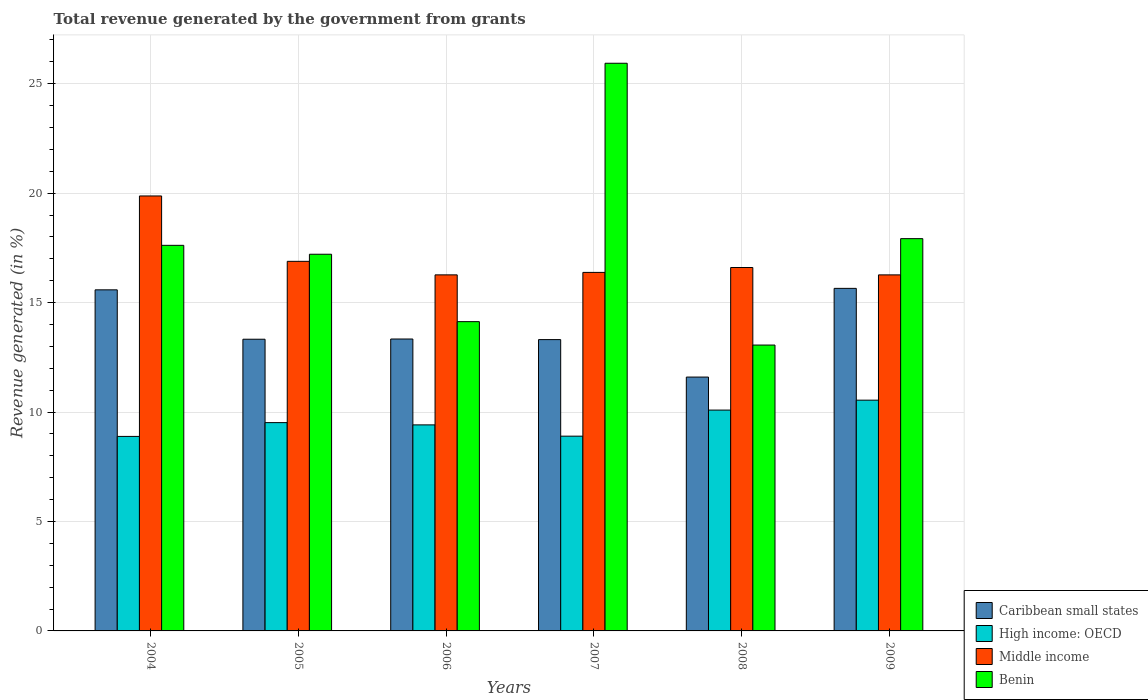Are the number of bars per tick equal to the number of legend labels?
Make the answer very short. Yes. Are the number of bars on each tick of the X-axis equal?
Offer a very short reply. Yes. How many bars are there on the 1st tick from the left?
Ensure brevity in your answer.  4. How many bars are there on the 5th tick from the right?
Give a very brief answer. 4. What is the label of the 2nd group of bars from the left?
Your response must be concise. 2005. What is the total revenue generated in Caribbean small states in 2008?
Provide a short and direct response. 11.6. Across all years, what is the maximum total revenue generated in High income: OECD?
Provide a succinct answer. 10.54. Across all years, what is the minimum total revenue generated in Benin?
Make the answer very short. 13.06. What is the total total revenue generated in Caribbean small states in the graph?
Your response must be concise. 82.81. What is the difference between the total revenue generated in Benin in 2004 and that in 2008?
Make the answer very short. 4.56. What is the difference between the total revenue generated in Middle income in 2009 and the total revenue generated in High income: OECD in 2004?
Keep it short and to the point. 7.38. What is the average total revenue generated in Middle income per year?
Provide a short and direct response. 17.05. In the year 2007, what is the difference between the total revenue generated in Caribbean small states and total revenue generated in High income: OECD?
Ensure brevity in your answer.  4.41. What is the ratio of the total revenue generated in Benin in 2006 to that in 2007?
Provide a succinct answer. 0.54. Is the difference between the total revenue generated in Caribbean small states in 2005 and 2008 greater than the difference between the total revenue generated in High income: OECD in 2005 and 2008?
Provide a succinct answer. Yes. What is the difference between the highest and the second highest total revenue generated in Benin?
Your response must be concise. 8.01. What is the difference between the highest and the lowest total revenue generated in Middle income?
Provide a short and direct response. 3.61. In how many years, is the total revenue generated in Middle income greater than the average total revenue generated in Middle income taken over all years?
Provide a succinct answer. 1. Is the sum of the total revenue generated in Middle income in 2006 and 2009 greater than the maximum total revenue generated in Caribbean small states across all years?
Provide a short and direct response. Yes. Is it the case that in every year, the sum of the total revenue generated in High income: OECD and total revenue generated in Benin is greater than the sum of total revenue generated in Caribbean small states and total revenue generated in Middle income?
Your answer should be very brief. Yes. What does the 1st bar from the left in 2008 represents?
Give a very brief answer. Caribbean small states. What does the 4th bar from the right in 2006 represents?
Provide a short and direct response. Caribbean small states. Is it the case that in every year, the sum of the total revenue generated in Caribbean small states and total revenue generated in Middle income is greater than the total revenue generated in High income: OECD?
Your answer should be compact. Yes. How many bars are there?
Make the answer very short. 24. How many years are there in the graph?
Your response must be concise. 6. Are the values on the major ticks of Y-axis written in scientific E-notation?
Your answer should be very brief. No. Does the graph contain grids?
Offer a terse response. Yes. Where does the legend appear in the graph?
Ensure brevity in your answer.  Bottom right. How many legend labels are there?
Your answer should be compact. 4. What is the title of the graph?
Give a very brief answer. Total revenue generated by the government from grants. Does "Turkey" appear as one of the legend labels in the graph?
Give a very brief answer. No. What is the label or title of the X-axis?
Make the answer very short. Years. What is the label or title of the Y-axis?
Offer a very short reply. Revenue generated (in %). What is the Revenue generated (in %) in Caribbean small states in 2004?
Provide a succinct answer. 15.58. What is the Revenue generated (in %) of High income: OECD in 2004?
Provide a succinct answer. 8.89. What is the Revenue generated (in %) of Middle income in 2004?
Your answer should be compact. 19.87. What is the Revenue generated (in %) of Benin in 2004?
Give a very brief answer. 17.62. What is the Revenue generated (in %) in Caribbean small states in 2005?
Offer a very short reply. 13.33. What is the Revenue generated (in %) in High income: OECD in 2005?
Give a very brief answer. 9.52. What is the Revenue generated (in %) of Middle income in 2005?
Ensure brevity in your answer.  16.89. What is the Revenue generated (in %) in Benin in 2005?
Your response must be concise. 17.21. What is the Revenue generated (in %) in Caribbean small states in 2006?
Ensure brevity in your answer.  13.34. What is the Revenue generated (in %) in High income: OECD in 2006?
Provide a succinct answer. 9.41. What is the Revenue generated (in %) of Middle income in 2006?
Your answer should be compact. 16.27. What is the Revenue generated (in %) in Benin in 2006?
Ensure brevity in your answer.  14.13. What is the Revenue generated (in %) of Caribbean small states in 2007?
Give a very brief answer. 13.31. What is the Revenue generated (in %) of High income: OECD in 2007?
Provide a succinct answer. 8.9. What is the Revenue generated (in %) of Middle income in 2007?
Offer a terse response. 16.38. What is the Revenue generated (in %) in Benin in 2007?
Give a very brief answer. 25.94. What is the Revenue generated (in %) in Caribbean small states in 2008?
Your response must be concise. 11.6. What is the Revenue generated (in %) of High income: OECD in 2008?
Provide a short and direct response. 10.09. What is the Revenue generated (in %) of Middle income in 2008?
Make the answer very short. 16.6. What is the Revenue generated (in %) in Benin in 2008?
Give a very brief answer. 13.06. What is the Revenue generated (in %) of Caribbean small states in 2009?
Provide a short and direct response. 15.65. What is the Revenue generated (in %) of High income: OECD in 2009?
Your response must be concise. 10.54. What is the Revenue generated (in %) in Middle income in 2009?
Offer a terse response. 16.27. What is the Revenue generated (in %) of Benin in 2009?
Give a very brief answer. 17.92. Across all years, what is the maximum Revenue generated (in %) in Caribbean small states?
Your answer should be very brief. 15.65. Across all years, what is the maximum Revenue generated (in %) in High income: OECD?
Keep it short and to the point. 10.54. Across all years, what is the maximum Revenue generated (in %) of Middle income?
Give a very brief answer. 19.87. Across all years, what is the maximum Revenue generated (in %) in Benin?
Provide a short and direct response. 25.94. Across all years, what is the minimum Revenue generated (in %) in Caribbean small states?
Provide a short and direct response. 11.6. Across all years, what is the minimum Revenue generated (in %) of High income: OECD?
Give a very brief answer. 8.89. Across all years, what is the minimum Revenue generated (in %) in Middle income?
Keep it short and to the point. 16.27. Across all years, what is the minimum Revenue generated (in %) in Benin?
Offer a very short reply. 13.06. What is the total Revenue generated (in %) of Caribbean small states in the graph?
Offer a very short reply. 82.81. What is the total Revenue generated (in %) in High income: OECD in the graph?
Keep it short and to the point. 57.35. What is the total Revenue generated (in %) in Middle income in the graph?
Your answer should be compact. 102.28. What is the total Revenue generated (in %) of Benin in the graph?
Your answer should be very brief. 105.88. What is the difference between the Revenue generated (in %) of Caribbean small states in 2004 and that in 2005?
Give a very brief answer. 2.26. What is the difference between the Revenue generated (in %) of High income: OECD in 2004 and that in 2005?
Offer a very short reply. -0.63. What is the difference between the Revenue generated (in %) in Middle income in 2004 and that in 2005?
Provide a succinct answer. 2.99. What is the difference between the Revenue generated (in %) of Benin in 2004 and that in 2005?
Your answer should be very brief. 0.41. What is the difference between the Revenue generated (in %) of Caribbean small states in 2004 and that in 2006?
Give a very brief answer. 2.25. What is the difference between the Revenue generated (in %) of High income: OECD in 2004 and that in 2006?
Your answer should be compact. -0.53. What is the difference between the Revenue generated (in %) in Middle income in 2004 and that in 2006?
Your answer should be compact. 3.61. What is the difference between the Revenue generated (in %) in Benin in 2004 and that in 2006?
Make the answer very short. 3.49. What is the difference between the Revenue generated (in %) of Caribbean small states in 2004 and that in 2007?
Ensure brevity in your answer.  2.27. What is the difference between the Revenue generated (in %) in High income: OECD in 2004 and that in 2007?
Give a very brief answer. -0.01. What is the difference between the Revenue generated (in %) of Middle income in 2004 and that in 2007?
Your answer should be very brief. 3.49. What is the difference between the Revenue generated (in %) in Benin in 2004 and that in 2007?
Your answer should be very brief. -8.32. What is the difference between the Revenue generated (in %) of Caribbean small states in 2004 and that in 2008?
Provide a short and direct response. 3.99. What is the difference between the Revenue generated (in %) of High income: OECD in 2004 and that in 2008?
Ensure brevity in your answer.  -1.2. What is the difference between the Revenue generated (in %) of Middle income in 2004 and that in 2008?
Your answer should be very brief. 3.27. What is the difference between the Revenue generated (in %) in Benin in 2004 and that in 2008?
Keep it short and to the point. 4.56. What is the difference between the Revenue generated (in %) in Caribbean small states in 2004 and that in 2009?
Provide a short and direct response. -0.07. What is the difference between the Revenue generated (in %) of High income: OECD in 2004 and that in 2009?
Your response must be concise. -1.66. What is the difference between the Revenue generated (in %) in Middle income in 2004 and that in 2009?
Offer a terse response. 3.61. What is the difference between the Revenue generated (in %) of Benin in 2004 and that in 2009?
Keep it short and to the point. -0.31. What is the difference between the Revenue generated (in %) of Caribbean small states in 2005 and that in 2006?
Offer a very short reply. -0.01. What is the difference between the Revenue generated (in %) in High income: OECD in 2005 and that in 2006?
Make the answer very short. 0.1. What is the difference between the Revenue generated (in %) of Middle income in 2005 and that in 2006?
Ensure brevity in your answer.  0.62. What is the difference between the Revenue generated (in %) of Benin in 2005 and that in 2006?
Your response must be concise. 3.08. What is the difference between the Revenue generated (in %) of Caribbean small states in 2005 and that in 2007?
Offer a very short reply. 0.02. What is the difference between the Revenue generated (in %) in High income: OECD in 2005 and that in 2007?
Your answer should be very brief. 0.62. What is the difference between the Revenue generated (in %) in Middle income in 2005 and that in 2007?
Keep it short and to the point. 0.51. What is the difference between the Revenue generated (in %) of Benin in 2005 and that in 2007?
Offer a terse response. -8.73. What is the difference between the Revenue generated (in %) in Caribbean small states in 2005 and that in 2008?
Make the answer very short. 1.73. What is the difference between the Revenue generated (in %) in High income: OECD in 2005 and that in 2008?
Provide a short and direct response. -0.57. What is the difference between the Revenue generated (in %) in Middle income in 2005 and that in 2008?
Keep it short and to the point. 0.28. What is the difference between the Revenue generated (in %) in Benin in 2005 and that in 2008?
Give a very brief answer. 4.15. What is the difference between the Revenue generated (in %) of Caribbean small states in 2005 and that in 2009?
Provide a short and direct response. -2.32. What is the difference between the Revenue generated (in %) in High income: OECD in 2005 and that in 2009?
Your answer should be compact. -1.03. What is the difference between the Revenue generated (in %) in Middle income in 2005 and that in 2009?
Provide a short and direct response. 0.62. What is the difference between the Revenue generated (in %) in Benin in 2005 and that in 2009?
Ensure brevity in your answer.  -0.71. What is the difference between the Revenue generated (in %) of Caribbean small states in 2006 and that in 2007?
Keep it short and to the point. 0.03. What is the difference between the Revenue generated (in %) of High income: OECD in 2006 and that in 2007?
Offer a terse response. 0.51. What is the difference between the Revenue generated (in %) in Middle income in 2006 and that in 2007?
Your answer should be very brief. -0.11. What is the difference between the Revenue generated (in %) of Benin in 2006 and that in 2007?
Offer a very short reply. -11.81. What is the difference between the Revenue generated (in %) in Caribbean small states in 2006 and that in 2008?
Make the answer very short. 1.74. What is the difference between the Revenue generated (in %) in High income: OECD in 2006 and that in 2008?
Offer a terse response. -0.68. What is the difference between the Revenue generated (in %) in Middle income in 2006 and that in 2008?
Your response must be concise. -0.34. What is the difference between the Revenue generated (in %) in Benin in 2006 and that in 2008?
Give a very brief answer. 1.07. What is the difference between the Revenue generated (in %) of Caribbean small states in 2006 and that in 2009?
Offer a very short reply. -2.31. What is the difference between the Revenue generated (in %) of High income: OECD in 2006 and that in 2009?
Keep it short and to the point. -1.13. What is the difference between the Revenue generated (in %) of Middle income in 2006 and that in 2009?
Offer a very short reply. 0. What is the difference between the Revenue generated (in %) of Benin in 2006 and that in 2009?
Provide a short and direct response. -3.79. What is the difference between the Revenue generated (in %) of Caribbean small states in 2007 and that in 2008?
Give a very brief answer. 1.71. What is the difference between the Revenue generated (in %) of High income: OECD in 2007 and that in 2008?
Your answer should be very brief. -1.19. What is the difference between the Revenue generated (in %) in Middle income in 2007 and that in 2008?
Your answer should be compact. -0.22. What is the difference between the Revenue generated (in %) in Benin in 2007 and that in 2008?
Provide a succinct answer. 12.87. What is the difference between the Revenue generated (in %) in Caribbean small states in 2007 and that in 2009?
Your answer should be compact. -2.34. What is the difference between the Revenue generated (in %) in High income: OECD in 2007 and that in 2009?
Offer a terse response. -1.64. What is the difference between the Revenue generated (in %) of Middle income in 2007 and that in 2009?
Your answer should be very brief. 0.11. What is the difference between the Revenue generated (in %) of Benin in 2007 and that in 2009?
Ensure brevity in your answer.  8.01. What is the difference between the Revenue generated (in %) of Caribbean small states in 2008 and that in 2009?
Offer a very short reply. -4.05. What is the difference between the Revenue generated (in %) in High income: OECD in 2008 and that in 2009?
Provide a succinct answer. -0.45. What is the difference between the Revenue generated (in %) in Middle income in 2008 and that in 2009?
Keep it short and to the point. 0.34. What is the difference between the Revenue generated (in %) of Benin in 2008 and that in 2009?
Make the answer very short. -4.86. What is the difference between the Revenue generated (in %) of Caribbean small states in 2004 and the Revenue generated (in %) of High income: OECD in 2005?
Your answer should be very brief. 6.07. What is the difference between the Revenue generated (in %) of Caribbean small states in 2004 and the Revenue generated (in %) of Middle income in 2005?
Your answer should be very brief. -1.3. What is the difference between the Revenue generated (in %) in Caribbean small states in 2004 and the Revenue generated (in %) in Benin in 2005?
Make the answer very short. -1.63. What is the difference between the Revenue generated (in %) in High income: OECD in 2004 and the Revenue generated (in %) in Middle income in 2005?
Your response must be concise. -8. What is the difference between the Revenue generated (in %) of High income: OECD in 2004 and the Revenue generated (in %) of Benin in 2005?
Your answer should be compact. -8.32. What is the difference between the Revenue generated (in %) in Middle income in 2004 and the Revenue generated (in %) in Benin in 2005?
Ensure brevity in your answer.  2.66. What is the difference between the Revenue generated (in %) of Caribbean small states in 2004 and the Revenue generated (in %) of High income: OECD in 2006?
Make the answer very short. 6.17. What is the difference between the Revenue generated (in %) in Caribbean small states in 2004 and the Revenue generated (in %) in Middle income in 2006?
Your response must be concise. -0.68. What is the difference between the Revenue generated (in %) of Caribbean small states in 2004 and the Revenue generated (in %) of Benin in 2006?
Your response must be concise. 1.45. What is the difference between the Revenue generated (in %) in High income: OECD in 2004 and the Revenue generated (in %) in Middle income in 2006?
Your response must be concise. -7.38. What is the difference between the Revenue generated (in %) of High income: OECD in 2004 and the Revenue generated (in %) of Benin in 2006?
Your answer should be compact. -5.24. What is the difference between the Revenue generated (in %) of Middle income in 2004 and the Revenue generated (in %) of Benin in 2006?
Give a very brief answer. 5.74. What is the difference between the Revenue generated (in %) in Caribbean small states in 2004 and the Revenue generated (in %) in High income: OECD in 2007?
Offer a terse response. 6.69. What is the difference between the Revenue generated (in %) in Caribbean small states in 2004 and the Revenue generated (in %) in Middle income in 2007?
Give a very brief answer. -0.8. What is the difference between the Revenue generated (in %) in Caribbean small states in 2004 and the Revenue generated (in %) in Benin in 2007?
Provide a short and direct response. -10.35. What is the difference between the Revenue generated (in %) of High income: OECD in 2004 and the Revenue generated (in %) of Middle income in 2007?
Offer a very short reply. -7.49. What is the difference between the Revenue generated (in %) of High income: OECD in 2004 and the Revenue generated (in %) of Benin in 2007?
Provide a short and direct response. -17.05. What is the difference between the Revenue generated (in %) in Middle income in 2004 and the Revenue generated (in %) in Benin in 2007?
Offer a terse response. -6.06. What is the difference between the Revenue generated (in %) of Caribbean small states in 2004 and the Revenue generated (in %) of High income: OECD in 2008?
Offer a very short reply. 5.49. What is the difference between the Revenue generated (in %) in Caribbean small states in 2004 and the Revenue generated (in %) in Middle income in 2008?
Offer a terse response. -1.02. What is the difference between the Revenue generated (in %) in Caribbean small states in 2004 and the Revenue generated (in %) in Benin in 2008?
Make the answer very short. 2.52. What is the difference between the Revenue generated (in %) of High income: OECD in 2004 and the Revenue generated (in %) of Middle income in 2008?
Your answer should be very brief. -7.72. What is the difference between the Revenue generated (in %) in High income: OECD in 2004 and the Revenue generated (in %) in Benin in 2008?
Keep it short and to the point. -4.17. What is the difference between the Revenue generated (in %) in Middle income in 2004 and the Revenue generated (in %) in Benin in 2008?
Offer a terse response. 6.81. What is the difference between the Revenue generated (in %) in Caribbean small states in 2004 and the Revenue generated (in %) in High income: OECD in 2009?
Make the answer very short. 5.04. What is the difference between the Revenue generated (in %) of Caribbean small states in 2004 and the Revenue generated (in %) of Middle income in 2009?
Provide a short and direct response. -0.68. What is the difference between the Revenue generated (in %) in Caribbean small states in 2004 and the Revenue generated (in %) in Benin in 2009?
Your answer should be very brief. -2.34. What is the difference between the Revenue generated (in %) of High income: OECD in 2004 and the Revenue generated (in %) of Middle income in 2009?
Give a very brief answer. -7.38. What is the difference between the Revenue generated (in %) of High income: OECD in 2004 and the Revenue generated (in %) of Benin in 2009?
Your answer should be compact. -9.04. What is the difference between the Revenue generated (in %) in Middle income in 2004 and the Revenue generated (in %) in Benin in 2009?
Offer a terse response. 1.95. What is the difference between the Revenue generated (in %) of Caribbean small states in 2005 and the Revenue generated (in %) of High income: OECD in 2006?
Your answer should be compact. 3.91. What is the difference between the Revenue generated (in %) in Caribbean small states in 2005 and the Revenue generated (in %) in Middle income in 2006?
Your answer should be compact. -2.94. What is the difference between the Revenue generated (in %) in Caribbean small states in 2005 and the Revenue generated (in %) in Benin in 2006?
Your answer should be compact. -0.8. What is the difference between the Revenue generated (in %) of High income: OECD in 2005 and the Revenue generated (in %) of Middle income in 2006?
Your response must be concise. -6.75. What is the difference between the Revenue generated (in %) in High income: OECD in 2005 and the Revenue generated (in %) in Benin in 2006?
Offer a terse response. -4.61. What is the difference between the Revenue generated (in %) of Middle income in 2005 and the Revenue generated (in %) of Benin in 2006?
Offer a terse response. 2.76. What is the difference between the Revenue generated (in %) of Caribbean small states in 2005 and the Revenue generated (in %) of High income: OECD in 2007?
Your response must be concise. 4.43. What is the difference between the Revenue generated (in %) in Caribbean small states in 2005 and the Revenue generated (in %) in Middle income in 2007?
Your answer should be very brief. -3.05. What is the difference between the Revenue generated (in %) of Caribbean small states in 2005 and the Revenue generated (in %) of Benin in 2007?
Make the answer very short. -12.61. What is the difference between the Revenue generated (in %) in High income: OECD in 2005 and the Revenue generated (in %) in Middle income in 2007?
Offer a terse response. -6.86. What is the difference between the Revenue generated (in %) in High income: OECD in 2005 and the Revenue generated (in %) in Benin in 2007?
Offer a terse response. -16.42. What is the difference between the Revenue generated (in %) of Middle income in 2005 and the Revenue generated (in %) of Benin in 2007?
Keep it short and to the point. -9.05. What is the difference between the Revenue generated (in %) in Caribbean small states in 2005 and the Revenue generated (in %) in High income: OECD in 2008?
Ensure brevity in your answer.  3.24. What is the difference between the Revenue generated (in %) of Caribbean small states in 2005 and the Revenue generated (in %) of Middle income in 2008?
Offer a very short reply. -3.28. What is the difference between the Revenue generated (in %) of Caribbean small states in 2005 and the Revenue generated (in %) of Benin in 2008?
Provide a succinct answer. 0.27. What is the difference between the Revenue generated (in %) in High income: OECD in 2005 and the Revenue generated (in %) in Middle income in 2008?
Ensure brevity in your answer.  -7.09. What is the difference between the Revenue generated (in %) of High income: OECD in 2005 and the Revenue generated (in %) of Benin in 2008?
Your answer should be compact. -3.54. What is the difference between the Revenue generated (in %) in Middle income in 2005 and the Revenue generated (in %) in Benin in 2008?
Provide a succinct answer. 3.82. What is the difference between the Revenue generated (in %) in Caribbean small states in 2005 and the Revenue generated (in %) in High income: OECD in 2009?
Keep it short and to the point. 2.78. What is the difference between the Revenue generated (in %) in Caribbean small states in 2005 and the Revenue generated (in %) in Middle income in 2009?
Your answer should be very brief. -2.94. What is the difference between the Revenue generated (in %) of Caribbean small states in 2005 and the Revenue generated (in %) of Benin in 2009?
Your answer should be compact. -4.6. What is the difference between the Revenue generated (in %) in High income: OECD in 2005 and the Revenue generated (in %) in Middle income in 2009?
Provide a succinct answer. -6.75. What is the difference between the Revenue generated (in %) of High income: OECD in 2005 and the Revenue generated (in %) of Benin in 2009?
Your response must be concise. -8.4. What is the difference between the Revenue generated (in %) of Middle income in 2005 and the Revenue generated (in %) of Benin in 2009?
Your answer should be very brief. -1.04. What is the difference between the Revenue generated (in %) in Caribbean small states in 2006 and the Revenue generated (in %) in High income: OECD in 2007?
Your answer should be very brief. 4.44. What is the difference between the Revenue generated (in %) in Caribbean small states in 2006 and the Revenue generated (in %) in Middle income in 2007?
Offer a terse response. -3.04. What is the difference between the Revenue generated (in %) in Caribbean small states in 2006 and the Revenue generated (in %) in Benin in 2007?
Provide a short and direct response. -12.6. What is the difference between the Revenue generated (in %) in High income: OECD in 2006 and the Revenue generated (in %) in Middle income in 2007?
Your answer should be compact. -6.97. What is the difference between the Revenue generated (in %) of High income: OECD in 2006 and the Revenue generated (in %) of Benin in 2007?
Offer a very short reply. -16.52. What is the difference between the Revenue generated (in %) in Middle income in 2006 and the Revenue generated (in %) in Benin in 2007?
Make the answer very short. -9.67. What is the difference between the Revenue generated (in %) of Caribbean small states in 2006 and the Revenue generated (in %) of High income: OECD in 2008?
Make the answer very short. 3.25. What is the difference between the Revenue generated (in %) in Caribbean small states in 2006 and the Revenue generated (in %) in Middle income in 2008?
Provide a succinct answer. -3.27. What is the difference between the Revenue generated (in %) in Caribbean small states in 2006 and the Revenue generated (in %) in Benin in 2008?
Ensure brevity in your answer.  0.28. What is the difference between the Revenue generated (in %) in High income: OECD in 2006 and the Revenue generated (in %) in Middle income in 2008?
Your answer should be compact. -7.19. What is the difference between the Revenue generated (in %) of High income: OECD in 2006 and the Revenue generated (in %) of Benin in 2008?
Offer a terse response. -3.65. What is the difference between the Revenue generated (in %) in Middle income in 2006 and the Revenue generated (in %) in Benin in 2008?
Provide a succinct answer. 3.21. What is the difference between the Revenue generated (in %) of Caribbean small states in 2006 and the Revenue generated (in %) of High income: OECD in 2009?
Make the answer very short. 2.79. What is the difference between the Revenue generated (in %) of Caribbean small states in 2006 and the Revenue generated (in %) of Middle income in 2009?
Provide a short and direct response. -2.93. What is the difference between the Revenue generated (in %) in Caribbean small states in 2006 and the Revenue generated (in %) in Benin in 2009?
Keep it short and to the point. -4.59. What is the difference between the Revenue generated (in %) of High income: OECD in 2006 and the Revenue generated (in %) of Middle income in 2009?
Make the answer very short. -6.85. What is the difference between the Revenue generated (in %) in High income: OECD in 2006 and the Revenue generated (in %) in Benin in 2009?
Your answer should be compact. -8.51. What is the difference between the Revenue generated (in %) in Middle income in 2006 and the Revenue generated (in %) in Benin in 2009?
Your response must be concise. -1.65. What is the difference between the Revenue generated (in %) in Caribbean small states in 2007 and the Revenue generated (in %) in High income: OECD in 2008?
Make the answer very short. 3.22. What is the difference between the Revenue generated (in %) in Caribbean small states in 2007 and the Revenue generated (in %) in Middle income in 2008?
Your answer should be very brief. -3.29. What is the difference between the Revenue generated (in %) in Caribbean small states in 2007 and the Revenue generated (in %) in Benin in 2008?
Offer a very short reply. 0.25. What is the difference between the Revenue generated (in %) in High income: OECD in 2007 and the Revenue generated (in %) in Middle income in 2008?
Give a very brief answer. -7.71. What is the difference between the Revenue generated (in %) of High income: OECD in 2007 and the Revenue generated (in %) of Benin in 2008?
Your answer should be very brief. -4.16. What is the difference between the Revenue generated (in %) in Middle income in 2007 and the Revenue generated (in %) in Benin in 2008?
Your answer should be compact. 3.32. What is the difference between the Revenue generated (in %) of Caribbean small states in 2007 and the Revenue generated (in %) of High income: OECD in 2009?
Keep it short and to the point. 2.77. What is the difference between the Revenue generated (in %) in Caribbean small states in 2007 and the Revenue generated (in %) in Middle income in 2009?
Your response must be concise. -2.96. What is the difference between the Revenue generated (in %) in Caribbean small states in 2007 and the Revenue generated (in %) in Benin in 2009?
Make the answer very short. -4.61. What is the difference between the Revenue generated (in %) in High income: OECD in 2007 and the Revenue generated (in %) in Middle income in 2009?
Your answer should be very brief. -7.37. What is the difference between the Revenue generated (in %) of High income: OECD in 2007 and the Revenue generated (in %) of Benin in 2009?
Make the answer very short. -9.02. What is the difference between the Revenue generated (in %) in Middle income in 2007 and the Revenue generated (in %) in Benin in 2009?
Your answer should be very brief. -1.54. What is the difference between the Revenue generated (in %) in Caribbean small states in 2008 and the Revenue generated (in %) in High income: OECD in 2009?
Keep it short and to the point. 1.06. What is the difference between the Revenue generated (in %) in Caribbean small states in 2008 and the Revenue generated (in %) in Middle income in 2009?
Ensure brevity in your answer.  -4.67. What is the difference between the Revenue generated (in %) of Caribbean small states in 2008 and the Revenue generated (in %) of Benin in 2009?
Provide a succinct answer. -6.32. What is the difference between the Revenue generated (in %) of High income: OECD in 2008 and the Revenue generated (in %) of Middle income in 2009?
Keep it short and to the point. -6.18. What is the difference between the Revenue generated (in %) in High income: OECD in 2008 and the Revenue generated (in %) in Benin in 2009?
Make the answer very short. -7.83. What is the difference between the Revenue generated (in %) of Middle income in 2008 and the Revenue generated (in %) of Benin in 2009?
Provide a succinct answer. -1.32. What is the average Revenue generated (in %) of Caribbean small states per year?
Offer a terse response. 13.8. What is the average Revenue generated (in %) of High income: OECD per year?
Provide a succinct answer. 9.56. What is the average Revenue generated (in %) of Middle income per year?
Give a very brief answer. 17.05. What is the average Revenue generated (in %) of Benin per year?
Your answer should be compact. 17.65. In the year 2004, what is the difference between the Revenue generated (in %) of Caribbean small states and Revenue generated (in %) of High income: OECD?
Provide a short and direct response. 6.7. In the year 2004, what is the difference between the Revenue generated (in %) in Caribbean small states and Revenue generated (in %) in Middle income?
Provide a short and direct response. -4.29. In the year 2004, what is the difference between the Revenue generated (in %) of Caribbean small states and Revenue generated (in %) of Benin?
Your response must be concise. -2.03. In the year 2004, what is the difference between the Revenue generated (in %) of High income: OECD and Revenue generated (in %) of Middle income?
Provide a short and direct response. -10.99. In the year 2004, what is the difference between the Revenue generated (in %) in High income: OECD and Revenue generated (in %) in Benin?
Offer a terse response. -8.73. In the year 2004, what is the difference between the Revenue generated (in %) in Middle income and Revenue generated (in %) in Benin?
Give a very brief answer. 2.26. In the year 2005, what is the difference between the Revenue generated (in %) of Caribbean small states and Revenue generated (in %) of High income: OECD?
Your answer should be very brief. 3.81. In the year 2005, what is the difference between the Revenue generated (in %) of Caribbean small states and Revenue generated (in %) of Middle income?
Ensure brevity in your answer.  -3.56. In the year 2005, what is the difference between the Revenue generated (in %) in Caribbean small states and Revenue generated (in %) in Benin?
Your response must be concise. -3.88. In the year 2005, what is the difference between the Revenue generated (in %) in High income: OECD and Revenue generated (in %) in Middle income?
Ensure brevity in your answer.  -7.37. In the year 2005, what is the difference between the Revenue generated (in %) of High income: OECD and Revenue generated (in %) of Benin?
Provide a succinct answer. -7.69. In the year 2005, what is the difference between the Revenue generated (in %) of Middle income and Revenue generated (in %) of Benin?
Make the answer very short. -0.32. In the year 2006, what is the difference between the Revenue generated (in %) of Caribbean small states and Revenue generated (in %) of High income: OECD?
Give a very brief answer. 3.92. In the year 2006, what is the difference between the Revenue generated (in %) of Caribbean small states and Revenue generated (in %) of Middle income?
Keep it short and to the point. -2.93. In the year 2006, what is the difference between the Revenue generated (in %) of Caribbean small states and Revenue generated (in %) of Benin?
Make the answer very short. -0.79. In the year 2006, what is the difference between the Revenue generated (in %) in High income: OECD and Revenue generated (in %) in Middle income?
Your response must be concise. -6.85. In the year 2006, what is the difference between the Revenue generated (in %) in High income: OECD and Revenue generated (in %) in Benin?
Provide a short and direct response. -4.72. In the year 2006, what is the difference between the Revenue generated (in %) of Middle income and Revenue generated (in %) of Benin?
Keep it short and to the point. 2.14. In the year 2007, what is the difference between the Revenue generated (in %) of Caribbean small states and Revenue generated (in %) of High income: OECD?
Your answer should be very brief. 4.41. In the year 2007, what is the difference between the Revenue generated (in %) in Caribbean small states and Revenue generated (in %) in Middle income?
Offer a very short reply. -3.07. In the year 2007, what is the difference between the Revenue generated (in %) of Caribbean small states and Revenue generated (in %) of Benin?
Your response must be concise. -12.63. In the year 2007, what is the difference between the Revenue generated (in %) of High income: OECD and Revenue generated (in %) of Middle income?
Give a very brief answer. -7.48. In the year 2007, what is the difference between the Revenue generated (in %) in High income: OECD and Revenue generated (in %) in Benin?
Ensure brevity in your answer.  -17.04. In the year 2007, what is the difference between the Revenue generated (in %) in Middle income and Revenue generated (in %) in Benin?
Provide a short and direct response. -9.55. In the year 2008, what is the difference between the Revenue generated (in %) of Caribbean small states and Revenue generated (in %) of High income: OECD?
Provide a short and direct response. 1.51. In the year 2008, what is the difference between the Revenue generated (in %) of Caribbean small states and Revenue generated (in %) of Middle income?
Give a very brief answer. -5.01. In the year 2008, what is the difference between the Revenue generated (in %) in Caribbean small states and Revenue generated (in %) in Benin?
Your answer should be compact. -1.46. In the year 2008, what is the difference between the Revenue generated (in %) in High income: OECD and Revenue generated (in %) in Middle income?
Provide a succinct answer. -6.51. In the year 2008, what is the difference between the Revenue generated (in %) in High income: OECD and Revenue generated (in %) in Benin?
Ensure brevity in your answer.  -2.97. In the year 2008, what is the difference between the Revenue generated (in %) in Middle income and Revenue generated (in %) in Benin?
Keep it short and to the point. 3.54. In the year 2009, what is the difference between the Revenue generated (in %) in Caribbean small states and Revenue generated (in %) in High income: OECD?
Provide a short and direct response. 5.11. In the year 2009, what is the difference between the Revenue generated (in %) of Caribbean small states and Revenue generated (in %) of Middle income?
Ensure brevity in your answer.  -0.62. In the year 2009, what is the difference between the Revenue generated (in %) of Caribbean small states and Revenue generated (in %) of Benin?
Keep it short and to the point. -2.27. In the year 2009, what is the difference between the Revenue generated (in %) in High income: OECD and Revenue generated (in %) in Middle income?
Your response must be concise. -5.72. In the year 2009, what is the difference between the Revenue generated (in %) in High income: OECD and Revenue generated (in %) in Benin?
Give a very brief answer. -7.38. In the year 2009, what is the difference between the Revenue generated (in %) in Middle income and Revenue generated (in %) in Benin?
Your answer should be very brief. -1.66. What is the ratio of the Revenue generated (in %) of Caribbean small states in 2004 to that in 2005?
Offer a terse response. 1.17. What is the ratio of the Revenue generated (in %) of High income: OECD in 2004 to that in 2005?
Keep it short and to the point. 0.93. What is the ratio of the Revenue generated (in %) of Middle income in 2004 to that in 2005?
Give a very brief answer. 1.18. What is the ratio of the Revenue generated (in %) of Benin in 2004 to that in 2005?
Your response must be concise. 1.02. What is the ratio of the Revenue generated (in %) of Caribbean small states in 2004 to that in 2006?
Give a very brief answer. 1.17. What is the ratio of the Revenue generated (in %) of High income: OECD in 2004 to that in 2006?
Offer a terse response. 0.94. What is the ratio of the Revenue generated (in %) of Middle income in 2004 to that in 2006?
Your answer should be compact. 1.22. What is the ratio of the Revenue generated (in %) in Benin in 2004 to that in 2006?
Ensure brevity in your answer.  1.25. What is the ratio of the Revenue generated (in %) in Caribbean small states in 2004 to that in 2007?
Give a very brief answer. 1.17. What is the ratio of the Revenue generated (in %) in Middle income in 2004 to that in 2007?
Your answer should be compact. 1.21. What is the ratio of the Revenue generated (in %) of Benin in 2004 to that in 2007?
Your response must be concise. 0.68. What is the ratio of the Revenue generated (in %) in Caribbean small states in 2004 to that in 2008?
Provide a short and direct response. 1.34. What is the ratio of the Revenue generated (in %) of High income: OECD in 2004 to that in 2008?
Make the answer very short. 0.88. What is the ratio of the Revenue generated (in %) of Middle income in 2004 to that in 2008?
Keep it short and to the point. 1.2. What is the ratio of the Revenue generated (in %) of Benin in 2004 to that in 2008?
Ensure brevity in your answer.  1.35. What is the ratio of the Revenue generated (in %) in Caribbean small states in 2004 to that in 2009?
Provide a succinct answer. 1. What is the ratio of the Revenue generated (in %) of High income: OECD in 2004 to that in 2009?
Your answer should be compact. 0.84. What is the ratio of the Revenue generated (in %) in Middle income in 2004 to that in 2009?
Offer a terse response. 1.22. What is the ratio of the Revenue generated (in %) in Benin in 2004 to that in 2009?
Your answer should be compact. 0.98. What is the ratio of the Revenue generated (in %) in High income: OECD in 2005 to that in 2006?
Your answer should be very brief. 1.01. What is the ratio of the Revenue generated (in %) of Middle income in 2005 to that in 2006?
Make the answer very short. 1.04. What is the ratio of the Revenue generated (in %) of Benin in 2005 to that in 2006?
Provide a short and direct response. 1.22. What is the ratio of the Revenue generated (in %) in Caribbean small states in 2005 to that in 2007?
Provide a short and direct response. 1. What is the ratio of the Revenue generated (in %) in High income: OECD in 2005 to that in 2007?
Give a very brief answer. 1.07. What is the ratio of the Revenue generated (in %) in Middle income in 2005 to that in 2007?
Your answer should be compact. 1.03. What is the ratio of the Revenue generated (in %) of Benin in 2005 to that in 2007?
Make the answer very short. 0.66. What is the ratio of the Revenue generated (in %) in Caribbean small states in 2005 to that in 2008?
Give a very brief answer. 1.15. What is the ratio of the Revenue generated (in %) of High income: OECD in 2005 to that in 2008?
Provide a short and direct response. 0.94. What is the ratio of the Revenue generated (in %) of Middle income in 2005 to that in 2008?
Provide a short and direct response. 1.02. What is the ratio of the Revenue generated (in %) in Benin in 2005 to that in 2008?
Your answer should be compact. 1.32. What is the ratio of the Revenue generated (in %) in Caribbean small states in 2005 to that in 2009?
Offer a very short reply. 0.85. What is the ratio of the Revenue generated (in %) of High income: OECD in 2005 to that in 2009?
Your response must be concise. 0.9. What is the ratio of the Revenue generated (in %) of Middle income in 2005 to that in 2009?
Make the answer very short. 1.04. What is the ratio of the Revenue generated (in %) in Benin in 2005 to that in 2009?
Ensure brevity in your answer.  0.96. What is the ratio of the Revenue generated (in %) in High income: OECD in 2006 to that in 2007?
Provide a succinct answer. 1.06. What is the ratio of the Revenue generated (in %) of Benin in 2006 to that in 2007?
Provide a succinct answer. 0.54. What is the ratio of the Revenue generated (in %) in Caribbean small states in 2006 to that in 2008?
Keep it short and to the point. 1.15. What is the ratio of the Revenue generated (in %) in High income: OECD in 2006 to that in 2008?
Make the answer very short. 0.93. What is the ratio of the Revenue generated (in %) of Middle income in 2006 to that in 2008?
Provide a succinct answer. 0.98. What is the ratio of the Revenue generated (in %) in Benin in 2006 to that in 2008?
Provide a short and direct response. 1.08. What is the ratio of the Revenue generated (in %) in Caribbean small states in 2006 to that in 2009?
Ensure brevity in your answer.  0.85. What is the ratio of the Revenue generated (in %) in High income: OECD in 2006 to that in 2009?
Give a very brief answer. 0.89. What is the ratio of the Revenue generated (in %) in Benin in 2006 to that in 2009?
Your answer should be very brief. 0.79. What is the ratio of the Revenue generated (in %) of Caribbean small states in 2007 to that in 2008?
Keep it short and to the point. 1.15. What is the ratio of the Revenue generated (in %) of High income: OECD in 2007 to that in 2008?
Ensure brevity in your answer.  0.88. What is the ratio of the Revenue generated (in %) in Middle income in 2007 to that in 2008?
Your response must be concise. 0.99. What is the ratio of the Revenue generated (in %) in Benin in 2007 to that in 2008?
Provide a short and direct response. 1.99. What is the ratio of the Revenue generated (in %) of Caribbean small states in 2007 to that in 2009?
Your answer should be compact. 0.85. What is the ratio of the Revenue generated (in %) in High income: OECD in 2007 to that in 2009?
Your response must be concise. 0.84. What is the ratio of the Revenue generated (in %) of Benin in 2007 to that in 2009?
Your answer should be very brief. 1.45. What is the ratio of the Revenue generated (in %) in Caribbean small states in 2008 to that in 2009?
Your answer should be very brief. 0.74. What is the ratio of the Revenue generated (in %) in Middle income in 2008 to that in 2009?
Make the answer very short. 1.02. What is the ratio of the Revenue generated (in %) of Benin in 2008 to that in 2009?
Ensure brevity in your answer.  0.73. What is the difference between the highest and the second highest Revenue generated (in %) in Caribbean small states?
Your answer should be very brief. 0.07. What is the difference between the highest and the second highest Revenue generated (in %) in High income: OECD?
Your response must be concise. 0.45. What is the difference between the highest and the second highest Revenue generated (in %) of Middle income?
Keep it short and to the point. 2.99. What is the difference between the highest and the second highest Revenue generated (in %) of Benin?
Offer a terse response. 8.01. What is the difference between the highest and the lowest Revenue generated (in %) of Caribbean small states?
Your answer should be compact. 4.05. What is the difference between the highest and the lowest Revenue generated (in %) of High income: OECD?
Provide a succinct answer. 1.66. What is the difference between the highest and the lowest Revenue generated (in %) of Middle income?
Offer a very short reply. 3.61. What is the difference between the highest and the lowest Revenue generated (in %) of Benin?
Give a very brief answer. 12.87. 